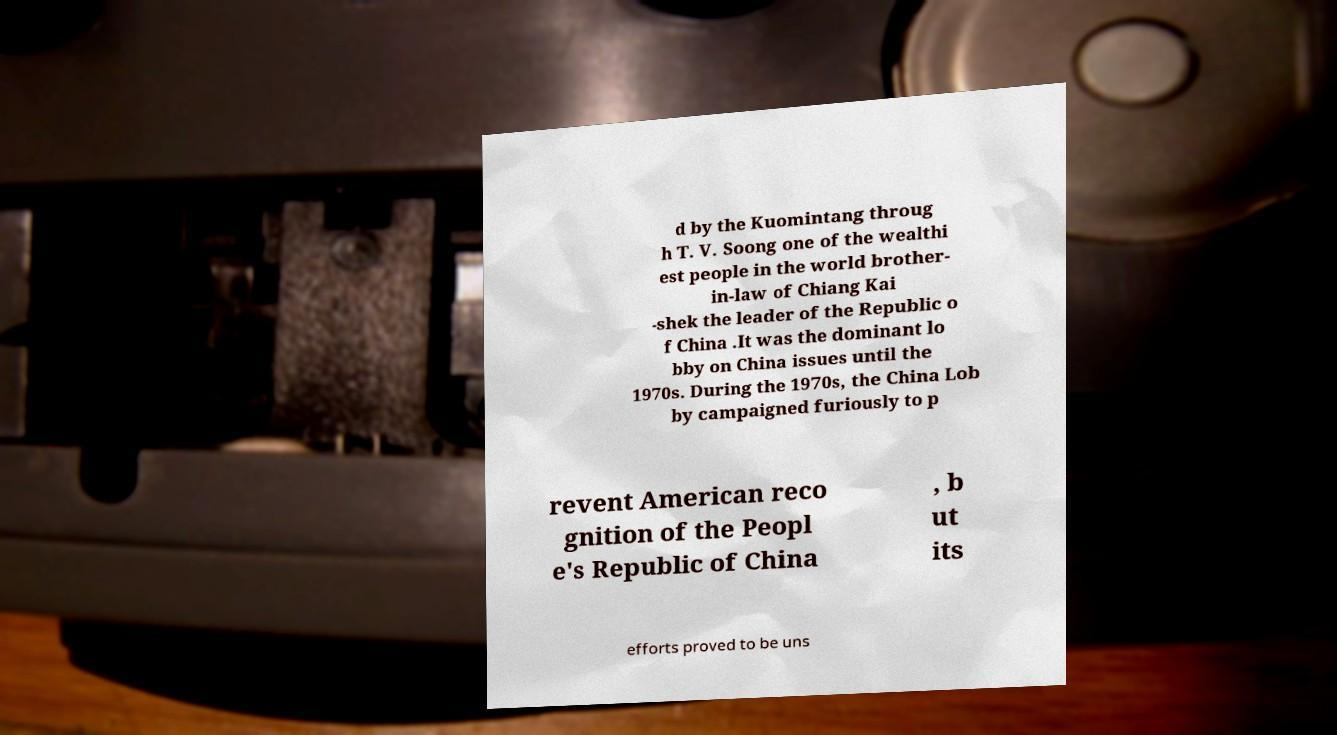For documentation purposes, I need the text within this image transcribed. Could you provide that? d by the Kuomintang throug h T. V. Soong one of the wealthi est people in the world brother- in-law of Chiang Kai -shek the leader of the Republic o f China .It was the dominant lo bby on China issues until the 1970s. During the 1970s, the China Lob by campaigned furiously to p revent American reco gnition of the Peopl e's Republic of China , b ut its efforts proved to be uns 